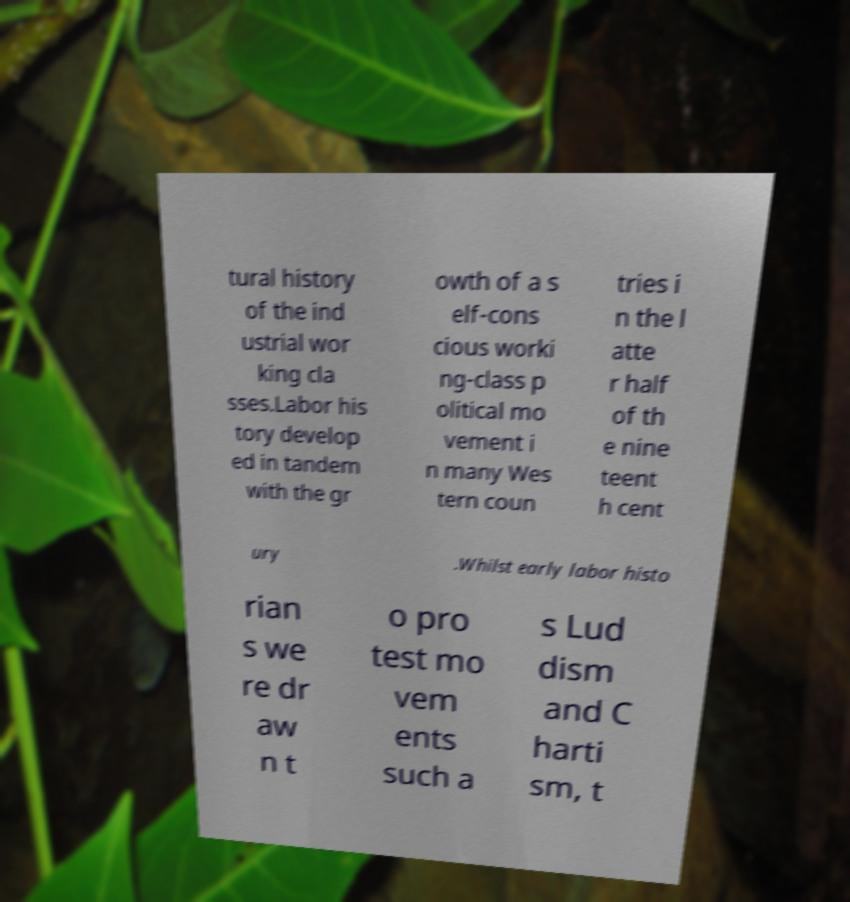Can you accurately transcribe the text from the provided image for me? tural history of the ind ustrial wor king cla sses.Labor his tory develop ed in tandem with the gr owth of a s elf-cons cious worki ng-class p olitical mo vement i n many Wes tern coun tries i n the l atte r half of th e nine teent h cent ury .Whilst early labor histo rian s we re dr aw n t o pro test mo vem ents such a s Lud dism and C harti sm, t 